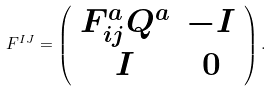<formula> <loc_0><loc_0><loc_500><loc_500>F ^ { I J } = \left ( \begin{array} { c c } { { F _ { i j } ^ { a } Q ^ { a } } } & { - I } \\ { I } & { 0 } \end{array} \right ) .</formula> 